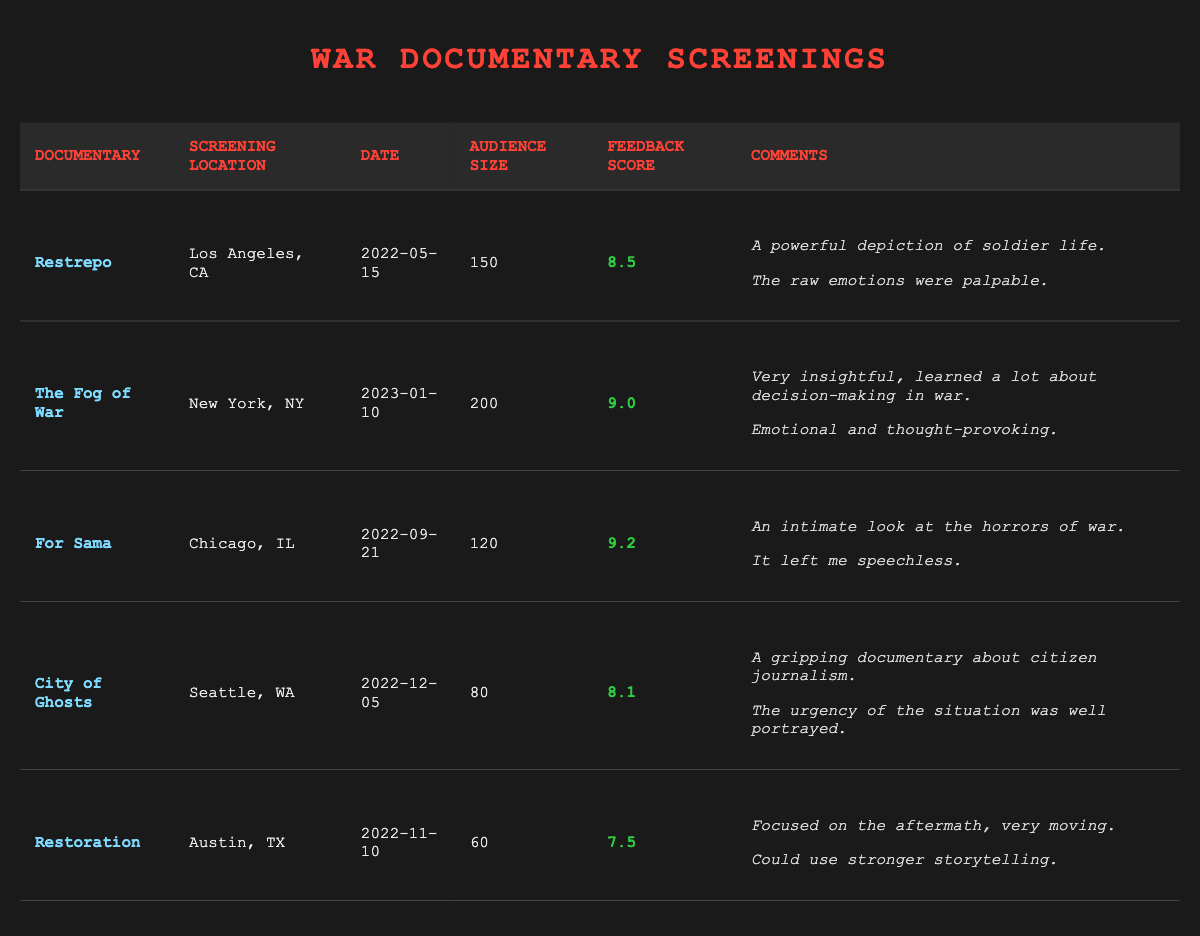What is the feedback score of "For Sama"? The table lists "For Sama" under the documentary title, and its corresponding feedback score is presented in the fifth column. The score is 9.2.
Answer: 9.2 Which documentary had the highest audience size? By examining the audience sizes in the table, "The Fog of War" has the largest audience with a count of 200 attendees.
Answer: The Fog of War What is the average audience size for all screenings? To calculate the average, add up all audience sizes: 150 (Restrepo) + 200 (The Fog of War) + 120 (For Sama) + 80 (City of Ghosts) + 60 (Restoration) = 610. Then, divide by the number of screenings (5): 610 / 5 = 122.
Answer: 122 Did "Restoration" receive a higher feedback score than "City of Ghosts"? Looking at the feedback scores, "Restoration" has a score of 7.5, while "City of Ghosts" has a score of 8.1. Since 7.5 is not greater than 8.1, the answer is no.
Answer: No How many documentaries received a feedback score of 9 or higher? By examining the feedback scores, we find that "The Fog of War" (9.0), "For Sama" (9.2) are the only documentaries with scores of 9 or higher. Thus, there are 2 documentaries meeting this criterion.
Answer: 2 Which documentary had the most positive audience comments? The table features comments for each documentary. "For Sama" has comments that express deep emotional impact ("An intimate look at the horrors of war" and "It left me speechless"), which are more emphatic compared to others. Thus, it can be inferred it had the most positive comments.
Answer: For Sama What was the date of the screening for "City of Ghosts"? Checking the screening date associated with "City of Ghosts" in the table, we see it took place on December 5, 2022.
Answer: December 5, 2022 What is the difference between the highest and lowest feedback scores? The highest score is 9.2 (For Sama) and the lowest is 7.5 (Restoration). The difference is calculated as 9.2 - 7.5 = 1.7.
Answer: 1.7 